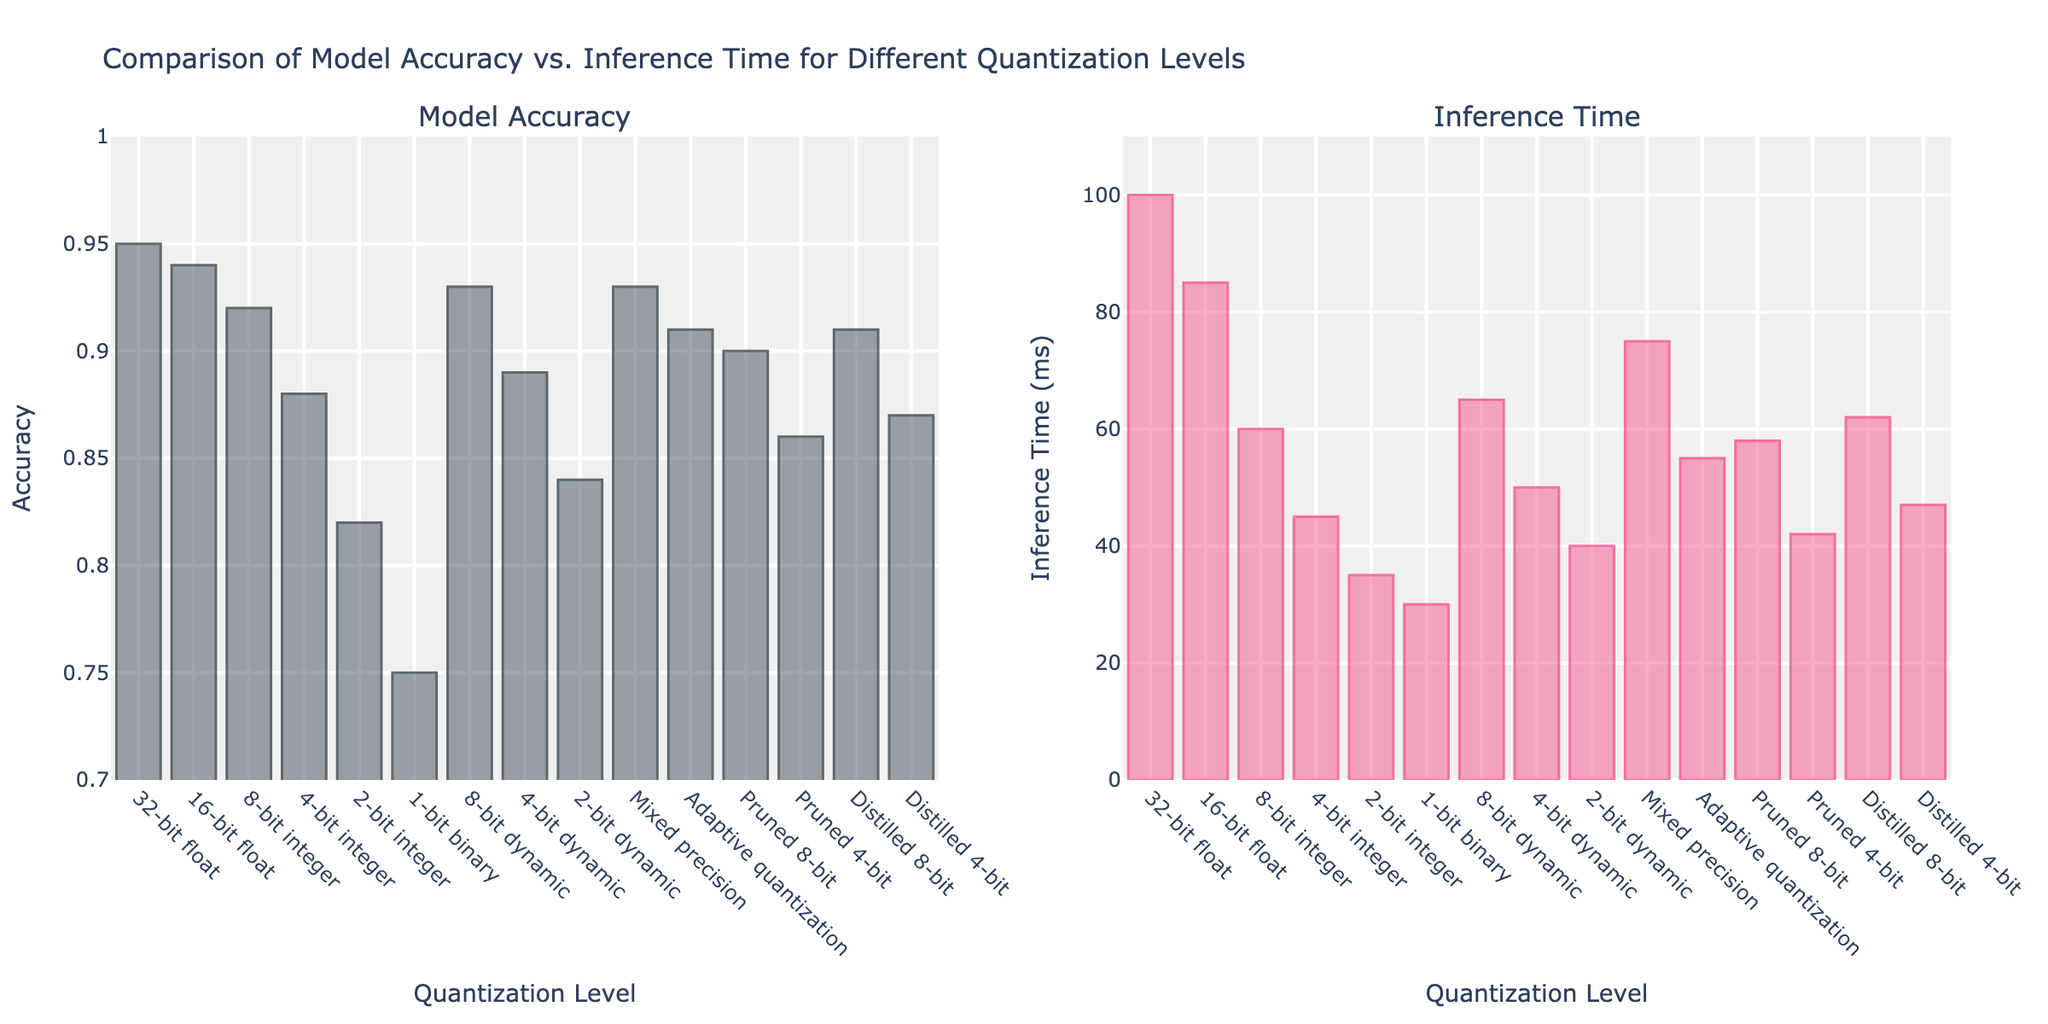Which quantization level provides the highest model accuracy? The highest bar in the 'Model Accuracy' subplot corresponds to the 32-bit float quantization level with an accuracy of 0.95
Answer: 32-bit float What is the difference in inference time between the 32-bit float and 1-bit binary quantization levels? The inference time for the 32-bit float is 100 ms and for the 1-bit binary is 30 ms. The difference is 100 - 30 = 70 ms
Answer: 70 ms Which quantization method offers a better trade-off between accuracy and inference time: Pruned 8-bit or Distilled 4-bit? Pruned 8-bit has an accuracy of 0.90 and an inference time of 58 ms, while Distilled 4-bit has an accuracy of 0.87 and an inference time of 47 ms. Although the Pruned 8-bit has higher accuracy, Distilled 4-bit has a lower inference time. Considering both metrics, Pruned 8-bit is preferred for higher accuracy
Answer: Pruned 8-bit How does the accuracy of Mixed precision compare to Adaptive quantization? The accuracy of Mixed precision is 0.93, while Adaptive quantization has an accuracy of 0.91. Mixed precision has a higher accuracy
Answer: Mixed precision What is the median value of inference time across all quantization levels shown? Sorting the inference times: 30, 35, 40, 42, 45, 47, 50, 55, 58, 60, 62, 65, 75, 85, 100. The median is the 8th value in the sorted list, which is 55
Answer: 55 ms Comparing the inference times, is the 16-bit float faster than the 8-bit integer? The inference time for the 16-bit float is 85 ms, whereas the 8-bit integer is 60 ms. The 8-bit integer is faster
Answer: 8-bit integer What visual difference in bar height can be seen between the 4-bit integer and the 2-bit dynamic quantization levels for model accuracy? In the 'Model Accuracy' subplot, the 4-bit integer bar is taller (0.88) than the 2-bit dynamic bar (0.84)
Answer: 4-bit integer bar is taller Which dynamic quantization level has the lowest inference time? In the 'Inference Time' subplot, the lowest bar among dynamic quantization levels corresponds to the 2-bit dynamic quantization level with an inference time of 40 ms
Answer: 2-bit dynamic 